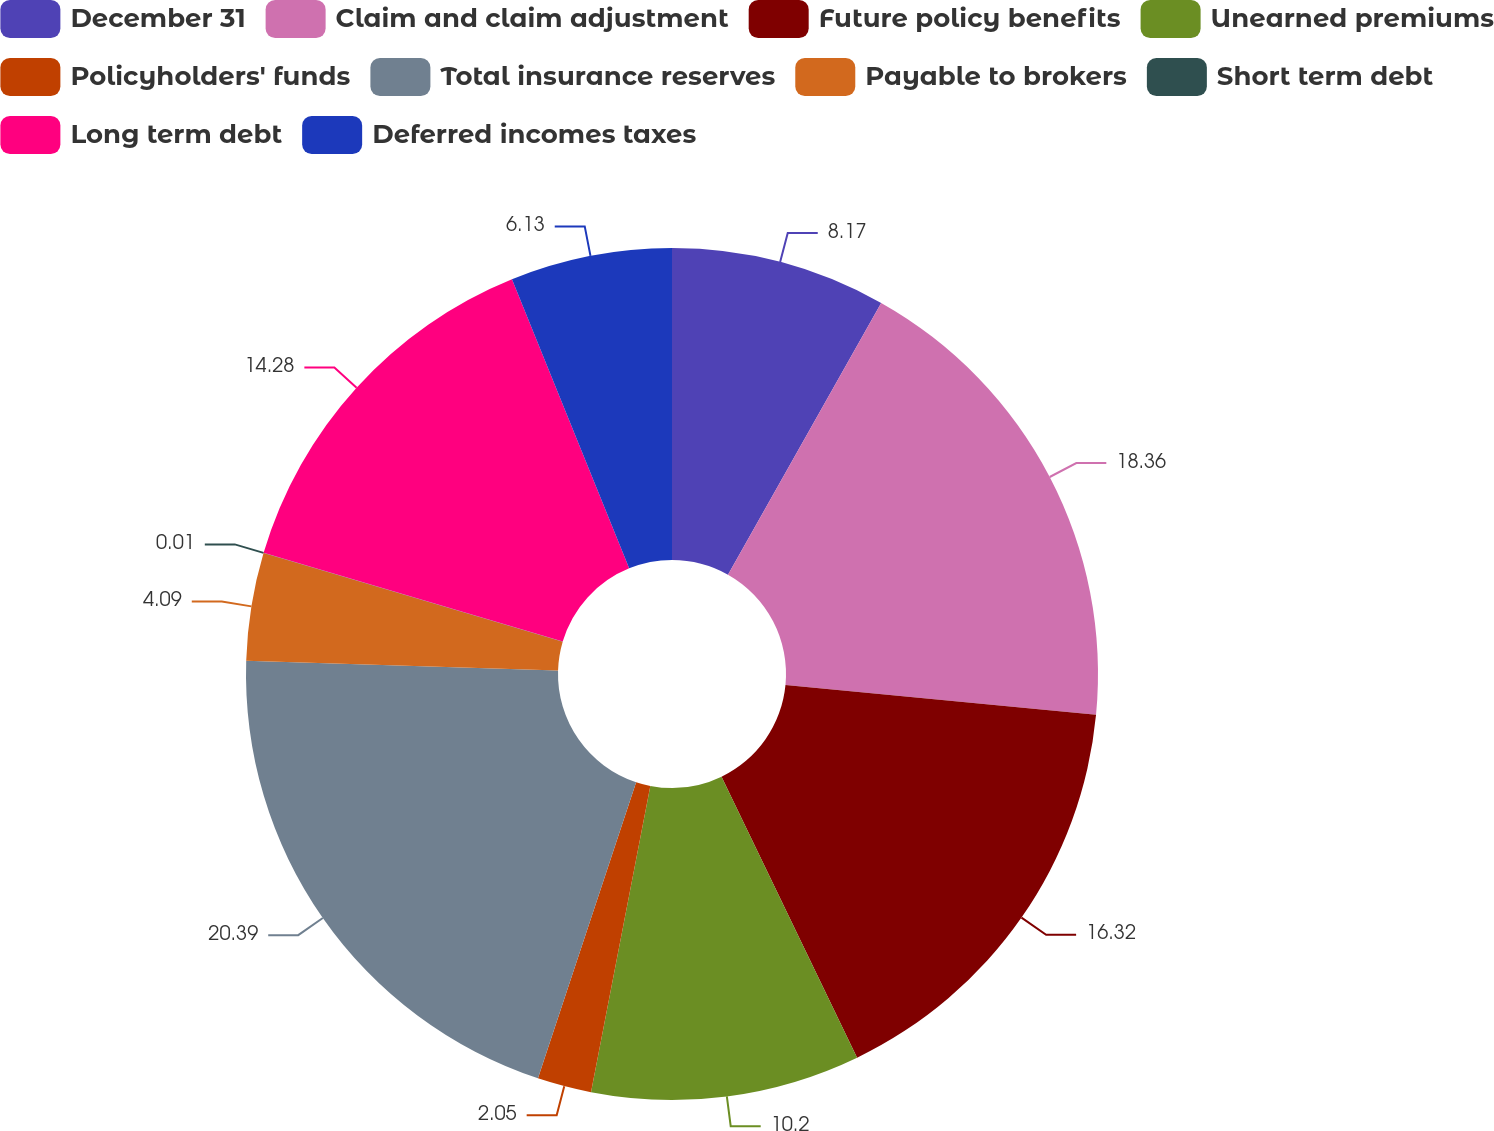Convert chart. <chart><loc_0><loc_0><loc_500><loc_500><pie_chart><fcel>December 31<fcel>Claim and claim adjustment<fcel>Future policy benefits<fcel>Unearned premiums<fcel>Policyholders' funds<fcel>Total insurance reserves<fcel>Payable to brokers<fcel>Short term debt<fcel>Long term debt<fcel>Deferred incomes taxes<nl><fcel>8.17%<fcel>18.36%<fcel>16.32%<fcel>10.2%<fcel>2.05%<fcel>20.4%<fcel>4.09%<fcel>0.01%<fcel>14.28%<fcel>6.13%<nl></chart> 